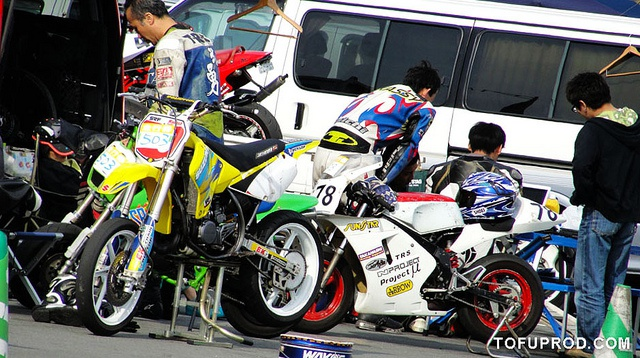Describe the objects in this image and their specific colors. I can see bus in brown, black, white, and gray tones, motorcycle in brown, black, gray, white, and darkgray tones, motorcycle in brown, black, white, gray, and darkgray tones, people in brown, black, blue, navy, and gray tones, and people in brown, black, white, blue, and gray tones in this image. 